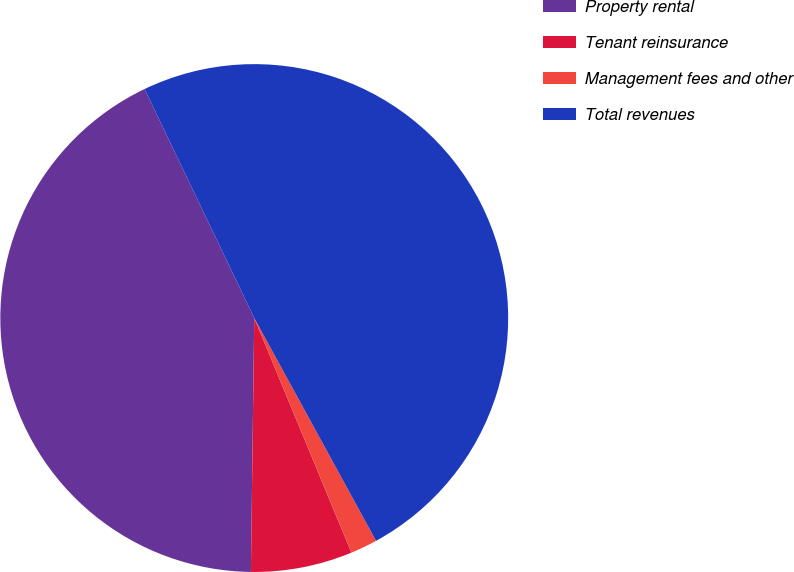<chart> <loc_0><loc_0><loc_500><loc_500><pie_chart><fcel>Property rental<fcel>Tenant reinsurance<fcel>Management fees and other<fcel>Total revenues<nl><fcel>42.68%<fcel>6.46%<fcel>1.71%<fcel>49.14%<nl></chart> 